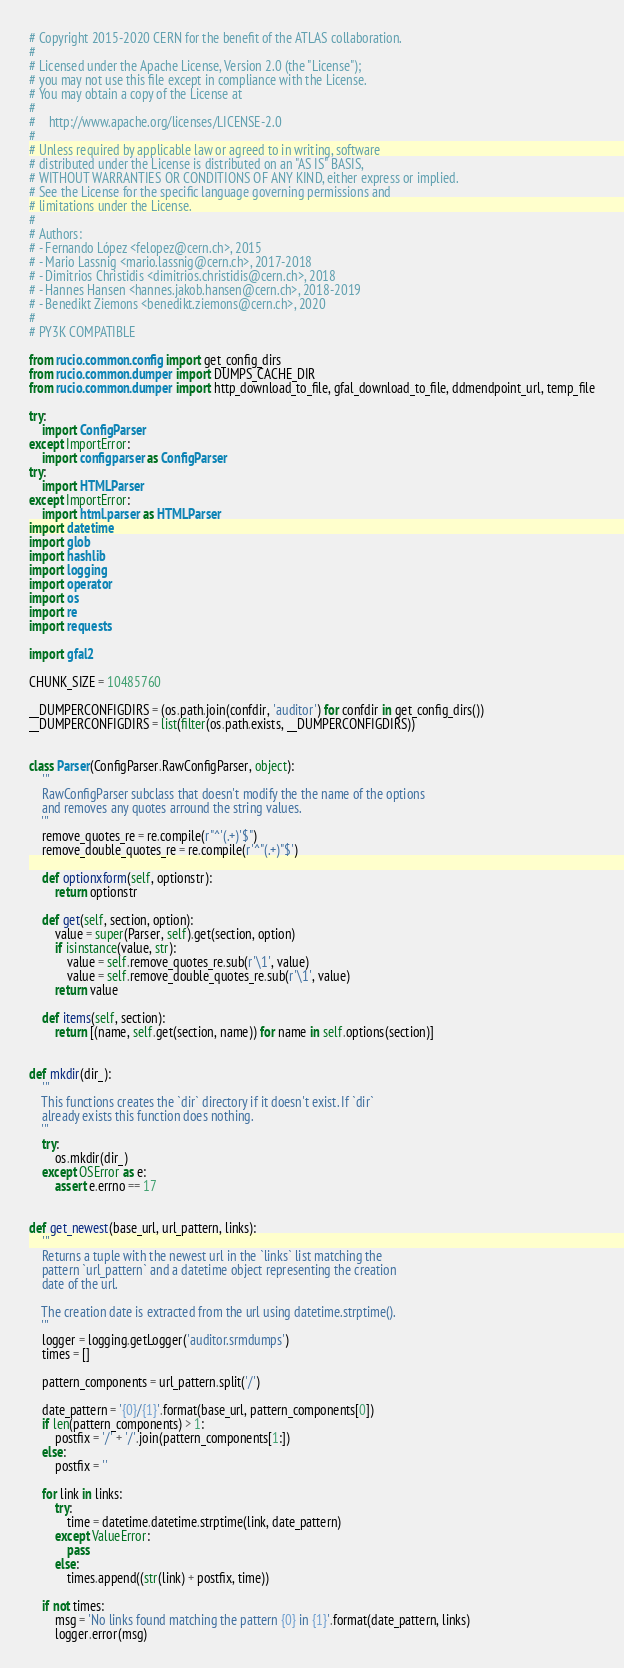<code> <loc_0><loc_0><loc_500><loc_500><_Python_># Copyright 2015-2020 CERN for the benefit of the ATLAS collaboration.
#
# Licensed under the Apache License, Version 2.0 (the "License");
# you may not use this file except in compliance with the License.
# You may obtain a copy of the License at
#
#    http://www.apache.org/licenses/LICENSE-2.0
#
# Unless required by applicable law or agreed to in writing, software
# distributed under the License is distributed on an "AS IS" BASIS,
# WITHOUT WARRANTIES OR CONDITIONS OF ANY KIND, either express or implied.
# See the License for the specific language governing permissions and
# limitations under the License.
#
# Authors:
# - Fernando López <felopez@cern.ch>, 2015
# - Mario Lassnig <mario.lassnig@cern.ch>, 2017-2018
# - Dimitrios Christidis <dimitrios.christidis@cern.ch>, 2018
# - Hannes Hansen <hannes.jakob.hansen@cern.ch>, 2018-2019
# - Benedikt Ziemons <benedikt.ziemons@cern.ch>, 2020
#
# PY3K COMPATIBLE

from rucio.common.config import get_config_dirs
from rucio.common.dumper import DUMPS_CACHE_DIR
from rucio.common.dumper import http_download_to_file, gfal_download_to_file, ddmendpoint_url, temp_file

try:
    import ConfigParser
except ImportError:
    import configparser as ConfigParser
try:
    import HTMLParser
except ImportError:
    import html.parser as HTMLParser
import datetime
import glob
import hashlib
import logging
import operator
import os
import re
import requests

import gfal2

CHUNK_SIZE = 10485760

__DUMPERCONFIGDIRS = (os.path.join(confdir, 'auditor') for confdir in get_config_dirs())
__DUMPERCONFIGDIRS = list(filter(os.path.exists, __DUMPERCONFIGDIRS))


class Parser(ConfigParser.RawConfigParser, object):
    '''
    RawConfigParser subclass that doesn't modify the the name of the options
    and removes any quotes arround the string values.
    '''
    remove_quotes_re = re.compile(r"^'(.+)'$")
    remove_double_quotes_re = re.compile(r'^"(.+)"$')

    def optionxform(self, optionstr):
        return optionstr

    def get(self, section, option):
        value = super(Parser, self).get(section, option)
        if isinstance(value, str):
            value = self.remove_quotes_re.sub(r'\1', value)
            value = self.remove_double_quotes_re.sub(r'\1', value)
        return value

    def items(self, section):
        return [(name, self.get(section, name)) for name in self.options(section)]


def mkdir(dir_):
    '''
    This functions creates the `dir` directory if it doesn't exist. If `dir`
    already exists this function does nothing.
    '''
    try:
        os.mkdir(dir_)
    except OSError as e:
        assert e.errno == 17


def get_newest(base_url, url_pattern, links):
    '''
    Returns a tuple with the newest url in the `links` list matching the
    pattern `url_pattern` and a datetime object representing the creation
    date of the url.

    The creation date is extracted from the url using datetime.strptime().
    '''
    logger = logging.getLogger('auditor.srmdumps')
    times = []

    pattern_components = url_pattern.split('/')

    date_pattern = '{0}/{1}'.format(base_url, pattern_components[0])
    if len(pattern_components) > 1:
        postfix = '/' + '/'.join(pattern_components[1:])
    else:
        postfix = ''

    for link in links:
        try:
            time = datetime.datetime.strptime(link, date_pattern)
        except ValueError:
            pass
        else:
            times.append((str(link) + postfix, time))

    if not times:
        msg = 'No links found matching the pattern {0} in {1}'.format(date_pattern, links)
        logger.error(msg)</code> 